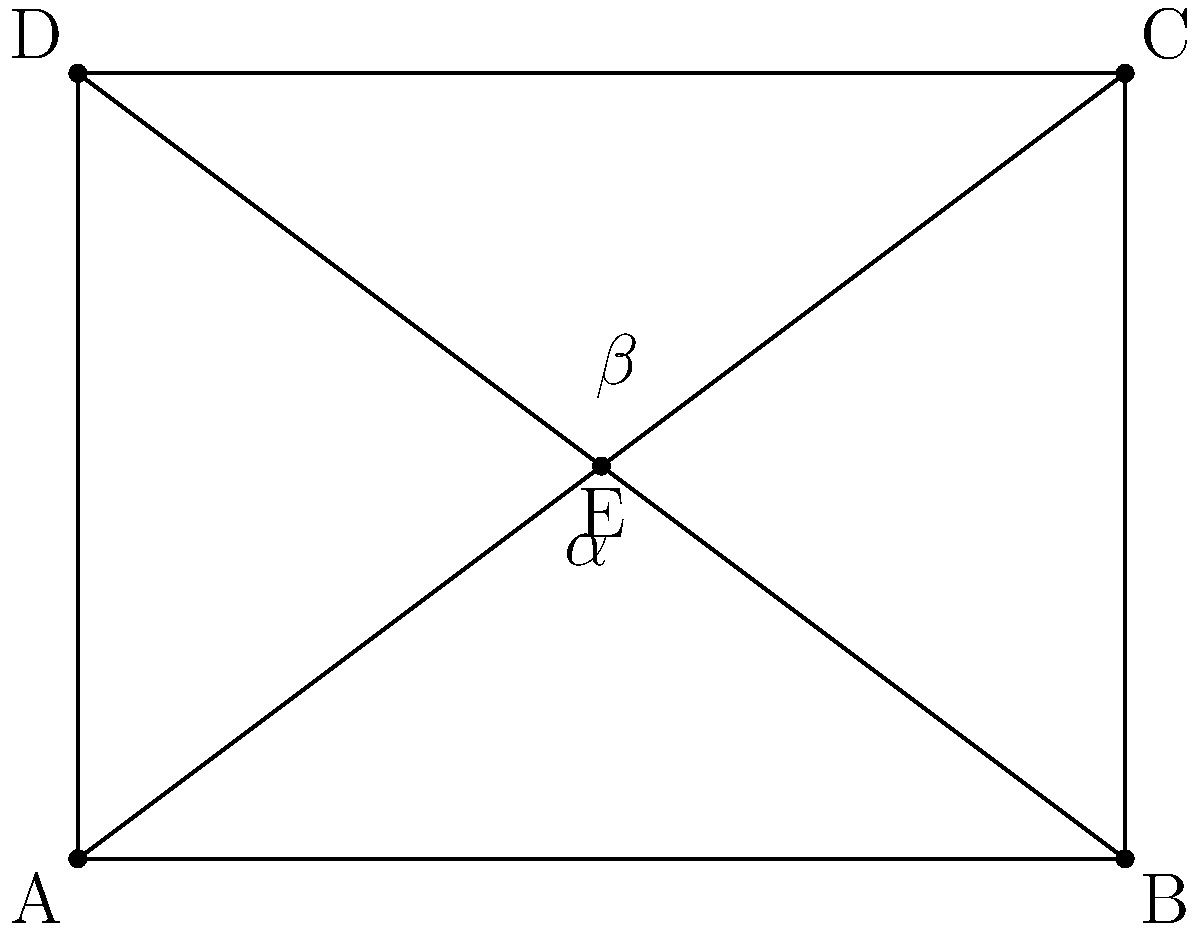In the circuit diagram above, two diagonal traces intersect at point E. Given that the rectangular PCB has dimensions of 4 cm × 3 cm, calculate the acute angle $\alpha$ formed between these traces. How might knowing this angle be relevant to protecting company secrets in PCB design? To solve this problem, we'll follow these steps:

1) First, we need to recognize that the two diagonal traces form two right triangles: AEC and BED.

2) We can calculate the angles using the arctangent function, as we know the dimensions of the rectangle.

3) For triangle AEC:
   $\tan(\alpha) = \frac{opposite}{adjacent} = \frac{3}{4}$
   $\alpha = \arctan(\frac{3}{4}) \approx 36.87°$

4) For triangle BED:
   $\tan(\beta) = \frac{opposite}{adjacent} = \frac{3}{4}$
   $\beta = \arctan(\frac{3}{4}) \approx 36.87°$

5) The acute angle between the traces is the sum of these two angles:
   $\alpha_{total} = \alpha + \beta = 36.87° + 36.87° = 73.74°$

6) Regarding company secrets: Knowing specific angles in PCB designs can be crucial for protecting intellectual property. Unique trace routing patterns, including specific angles, can be part of a company's proprietary design techniques. These patterns might optimize signal integrity, reduce electromagnetic interference, or improve manufacturing efficiency. By safeguarding this information, a company can maintain its competitive edge in product development.
Answer: $73.74°$ 